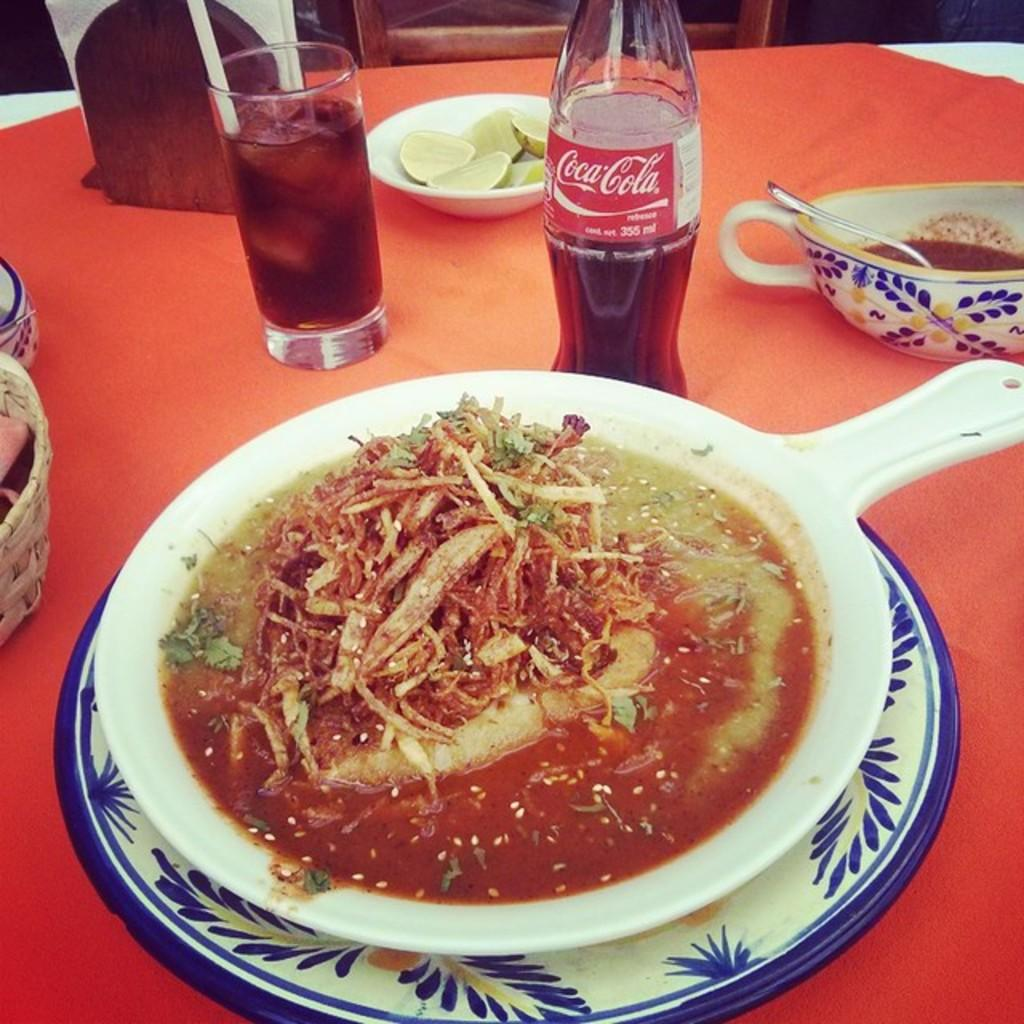What piece of furniture is present in the image? There is a table in the image. What is placed on the table? There is a glass, a cool drink bottle, a bowl with lemons, a cup, and a plate on the table. Can you describe the contents of the bowl on the table? The bowl on the table contains lemons. Where is the shelf located in the image? There is no shelf present in the image. What type of stitch is used to hold the lemons together in the bowl? The lemons are not stitched together in the bowl; they are simply placed in the bowl. 